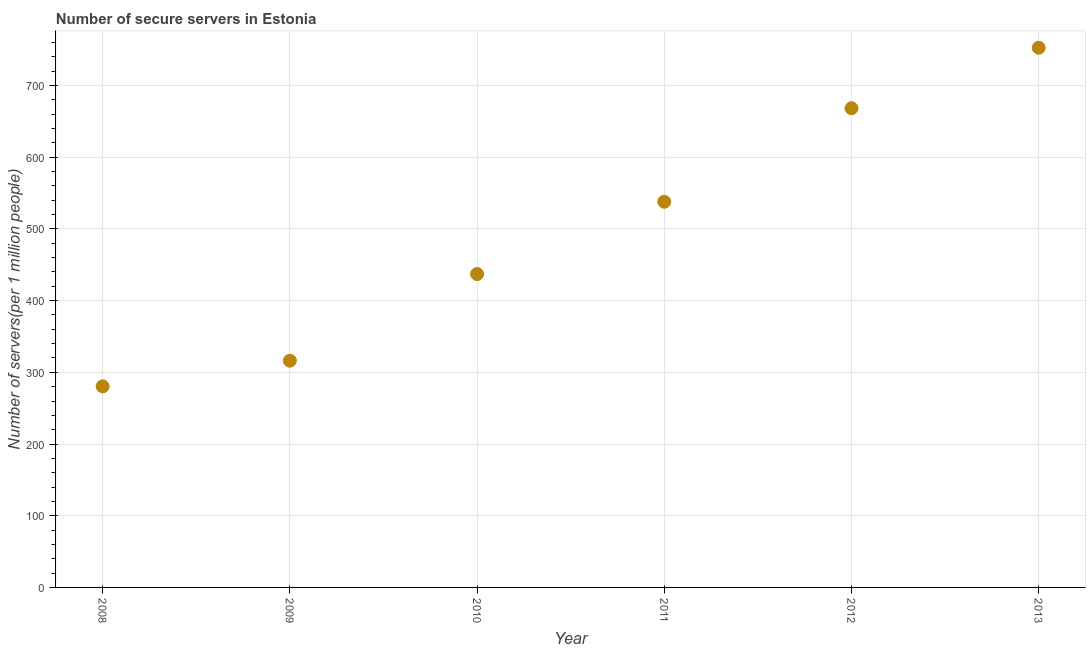What is the number of secure internet servers in 2010?
Keep it short and to the point. 437.11. Across all years, what is the maximum number of secure internet servers?
Your answer should be compact. 752.66. Across all years, what is the minimum number of secure internet servers?
Offer a terse response. 280.46. In which year was the number of secure internet servers maximum?
Keep it short and to the point. 2013. In which year was the number of secure internet servers minimum?
Make the answer very short. 2008. What is the sum of the number of secure internet servers?
Make the answer very short. 2992.66. What is the difference between the number of secure internet servers in 2011 and 2012?
Keep it short and to the point. -130.45. What is the average number of secure internet servers per year?
Make the answer very short. 498.78. What is the median number of secure internet servers?
Provide a short and direct response. 487.49. Do a majority of the years between 2011 and 2012 (inclusive) have number of secure internet servers greater than 80 ?
Provide a succinct answer. Yes. What is the ratio of the number of secure internet servers in 2008 to that in 2009?
Your response must be concise. 0.89. Is the difference between the number of secure internet servers in 2010 and 2012 greater than the difference between any two years?
Offer a terse response. No. What is the difference between the highest and the second highest number of secure internet servers?
Ensure brevity in your answer.  84.33. What is the difference between the highest and the lowest number of secure internet servers?
Give a very brief answer. 472.2. How many dotlines are there?
Your answer should be compact. 1. Does the graph contain any zero values?
Your response must be concise. No. What is the title of the graph?
Provide a short and direct response. Number of secure servers in Estonia. What is the label or title of the X-axis?
Provide a short and direct response. Year. What is the label or title of the Y-axis?
Offer a very short reply. Number of servers(per 1 million people). What is the Number of servers(per 1 million people) in 2008?
Offer a terse response. 280.46. What is the Number of servers(per 1 million people) in 2009?
Provide a short and direct response. 316.22. What is the Number of servers(per 1 million people) in 2010?
Make the answer very short. 437.11. What is the Number of servers(per 1 million people) in 2011?
Offer a terse response. 537.88. What is the Number of servers(per 1 million people) in 2012?
Your answer should be very brief. 668.33. What is the Number of servers(per 1 million people) in 2013?
Keep it short and to the point. 752.66. What is the difference between the Number of servers(per 1 million people) in 2008 and 2009?
Offer a terse response. -35.76. What is the difference between the Number of servers(per 1 million people) in 2008 and 2010?
Your answer should be compact. -156.65. What is the difference between the Number of servers(per 1 million people) in 2008 and 2011?
Ensure brevity in your answer.  -257.42. What is the difference between the Number of servers(per 1 million people) in 2008 and 2012?
Ensure brevity in your answer.  -387.87. What is the difference between the Number of servers(per 1 million people) in 2008 and 2013?
Your answer should be compact. -472.2. What is the difference between the Number of servers(per 1 million people) in 2009 and 2010?
Your response must be concise. -120.89. What is the difference between the Number of servers(per 1 million people) in 2009 and 2011?
Provide a short and direct response. -221.66. What is the difference between the Number of servers(per 1 million people) in 2009 and 2012?
Offer a terse response. -352.11. What is the difference between the Number of servers(per 1 million people) in 2009 and 2013?
Provide a short and direct response. -436.44. What is the difference between the Number of servers(per 1 million people) in 2010 and 2011?
Your answer should be compact. -100.77. What is the difference between the Number of servers(per 1 million people) in 2010 and 2012?
Your response must be concise. -231.22. What is the difference between the Number of servers(per 1 million people) in 2010 and 2013?
Provide a succinct answer. -315.55. What is the difference between the Number of servers(per 1 million people) in 2011 and 2012?
Provide a short and direct response. -130.45. What is the difference between the Number of servers(per 1 million people) in 2011 and 2013?
Provide a succinct answer. -214.78. What is the difference between the Number of servers(per 1 million people) in 2012 and 2013?
Give a very brief answer. -84.33. What is the ratio of the Number of servers(per 1 million people) in 2008 to that in 2009?
Offer a terse response. 0.89. What is the ratio of the Number of servers(per 1 million people) in 2008 to that in 2010?
Your answer should be compact. 0.64. What is the ratio of the Number of servers(per 1 million people) in 2008 to that in 2011?
Your answer should be very brief. 0.52. What is the ratio of the Number of servers(per 1 million people) in 2008 to that in 2012?
Give a very brief answer. 0.42. What is the ratio of the Number of servers(per 1 million people) in 2008 to that in 2013?
Your answer should be very brief. 0.37. What is the ratio of the Number of servers(per 1 million people) in 2009 to that in 2010?
Your answer should be compact. 0.72. What is the ratio of the Number of servers(per 1 million people) in 2009 to that in 2011?
Give a very brief answer. 0.59. What is the ratio of the Number of servers(per 1 million people) in 2009 to that in 2012?
Your answer should be compact. 0.47. What is the ratio of the Number of servers(per 1 million people) in 2009 to that in 2013?
Offer a terse response. 0.42. What is the ratio of the Number of servers(per 1 million people) in 2010 to that in 2011?
Keep it short and to the point. 0.81. What is the ratio of the Number of servers(per 1 million people) in 2010 to that in 2012?
Your response must be concise. 0.65. What is the ratio of the Number of servers(per 1 million people) in 2010 to that in 2013?
Provide a short and direct response. 0.58. What is the ratio of the Number of servers(per 1 million people) in 2011 to that in 2012?
Keep it short and to the point. 0.81. What is the ratio of the Number of servers(per 1 million people) in 2011 to that in 2013?
Give a very brief answer. 0.71. What is the ratio of the Number of servers(per 1 million people) in 2012 to that in 2013?
Ensure brevity in your answer.  0.89. 